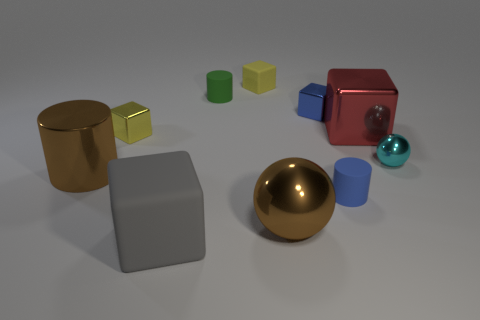Does the large metal cylinder have the same color as the big sphere?
Your answer should be compact. Yes. There is a object that is the same color as the large metallic sphere; what is its size?
Provide a short and direct response. Large. How many objects are either matte blocks in front of the red metallic cube or big brown things that are left of the small yellow rubber object?
Make the answer very short. 2. How big is the gray matte cube to the left of the cylinder behind the red metallic thing?
Provide a succinct answer. Large. What size is the gray rubber block?
Your answer should be compact. Large. Does the large metal object that is on the right side of the large brown ball have the same color as the small shiny object left of the big matte cube?
Ensure brevity in your answer.  No. How many other things are made of the same material as the small cyan sphere?
Provide a short and direct response. 5. Is there a large gray sphere?
Give a very brief answer. No. Is the cylinder behind the cyan object made of the same material as the cyan thing?
Your answer should be compact. No. What is the material of the large red thing that is the same shape as the blue shiny object?
Your answer should be compact. Metal. 